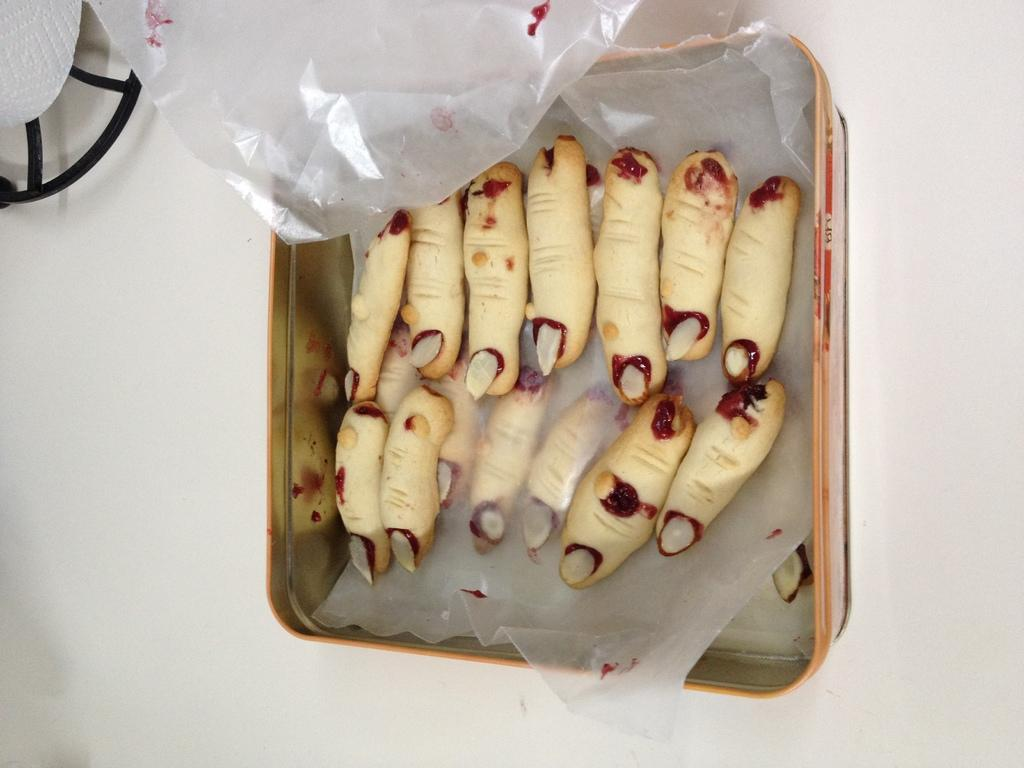What is inside the box in the image? There are food items in a box. Where is the box located in the image? The box is on a platform. What type of covering is visible in the image? There are polythene covers visible. Can you describe the object present in the image? Unfortunately, the provided facts do not give enough information to describe the object present in the image. What type of button does the father wear in the image? There is no father or button present in the image. 